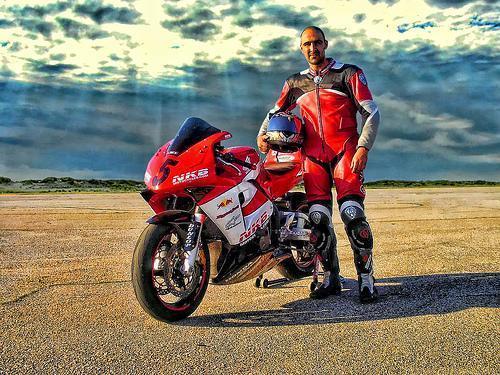How many people are pictured?
Give a very brief answer. 1. How many people are there?
Give a very brief answer. 1. 